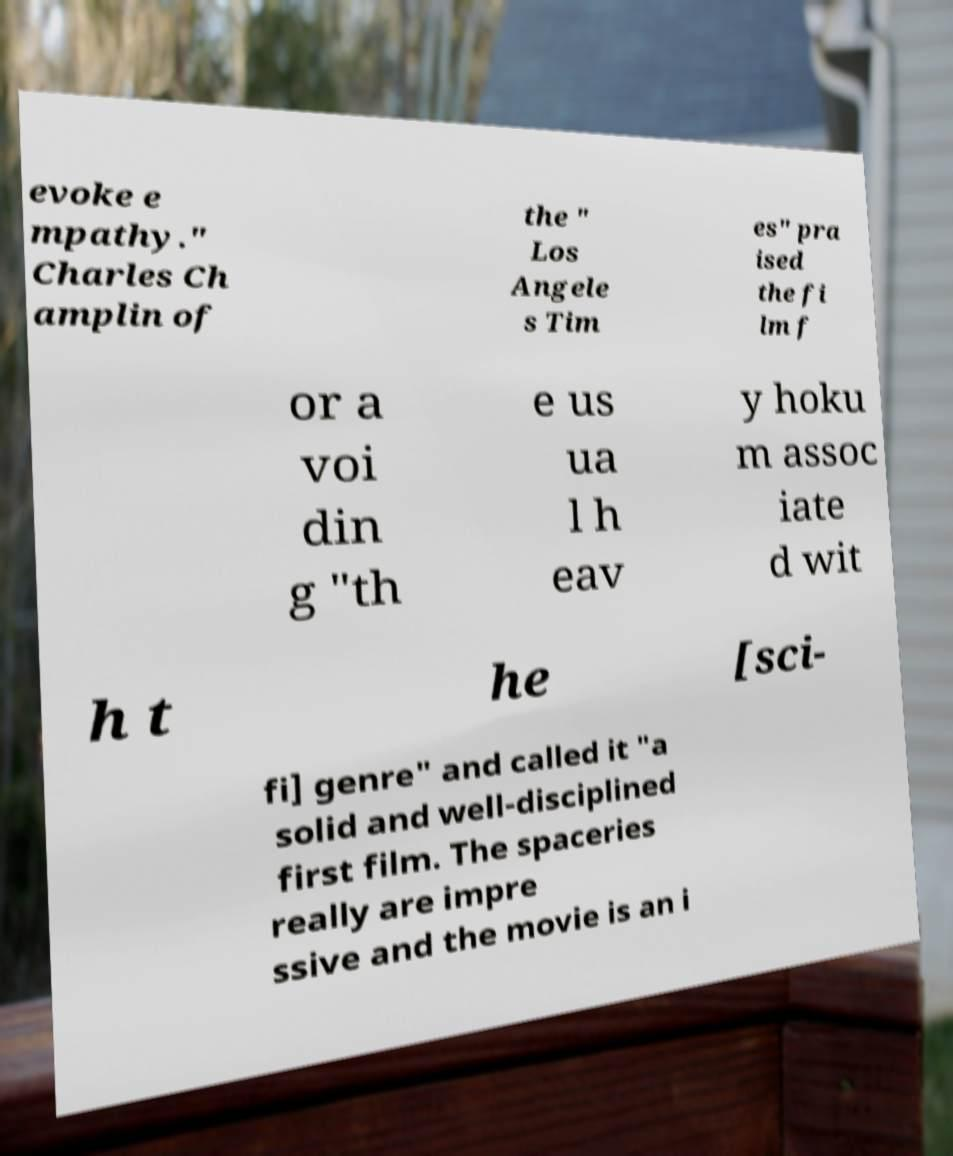Can you accurately transcribe the text from the provided image for me? evoke e mpathy." Charles Ch amplin of the " Los Angele s Tim es" pra ised the fi lm f or a voi din g "th e us ua l h eav y hoku m assoc iate d wit h t he [sci- fi] genre" and called it "a solid and well-disciplined first film. The spaceries really are impre ssive and the movie is an i 